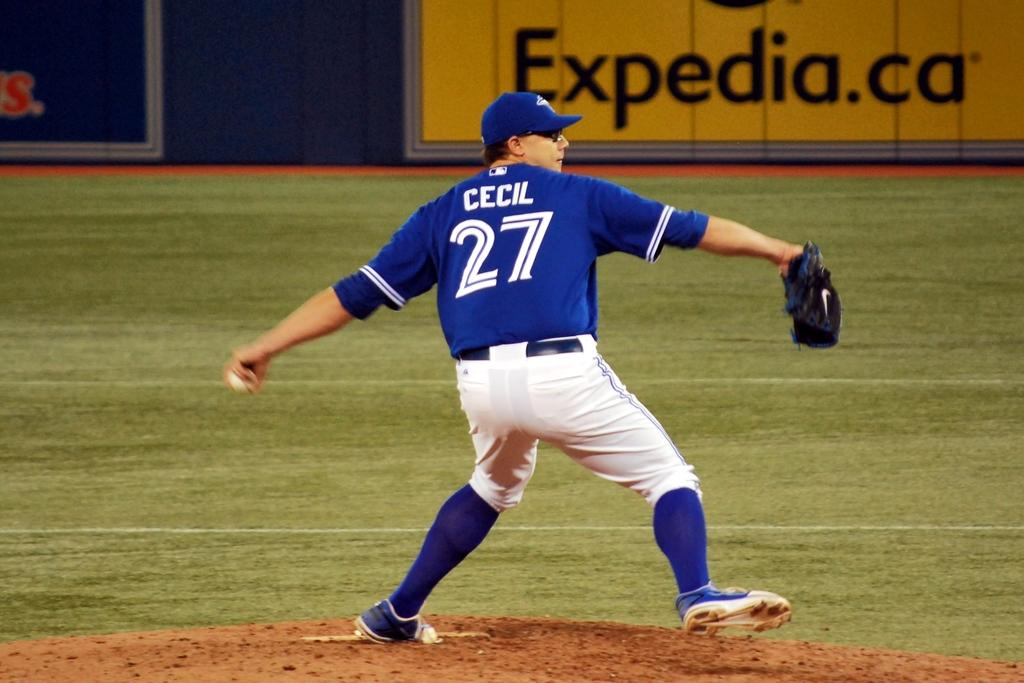<image>
Write a terse but informative summary of the picture. CECIL 27 is written on the back of a pitchers shirt. 